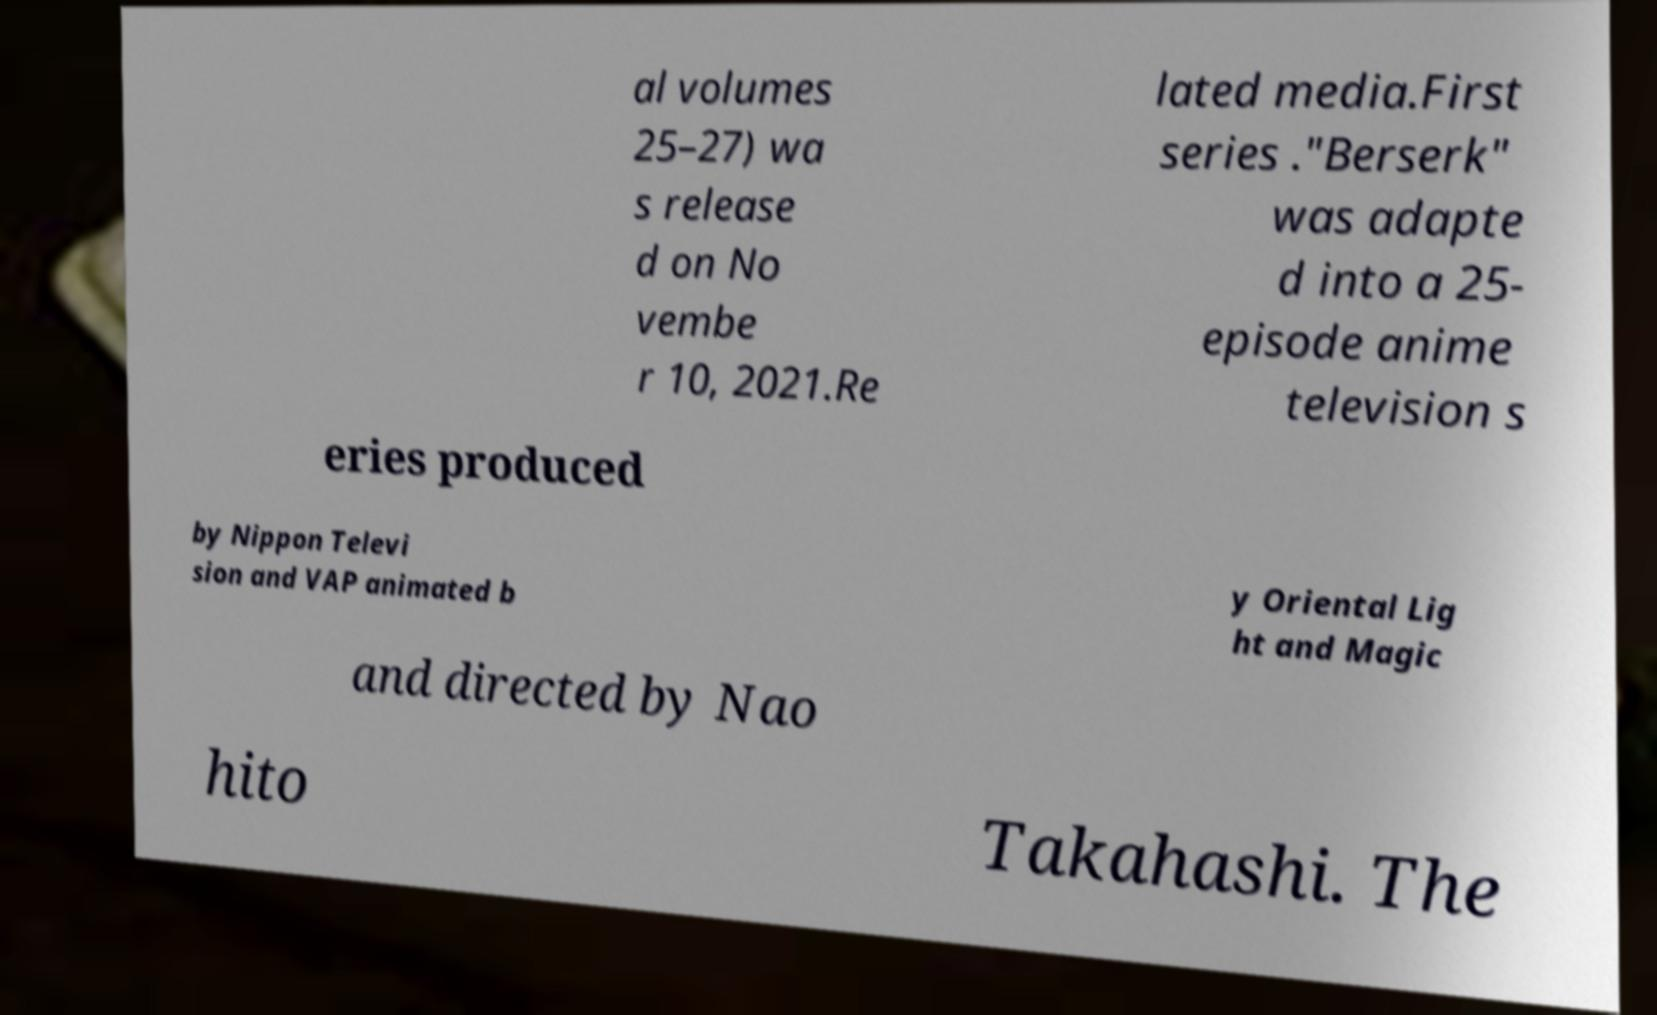What messages or text are displayed in this image? I need them in a readable, typed format. al volumes 25–27) wa s release d on No vembe r 10, 2021.Re lated media.First series ."Berserk" was adapte d into a 25- episode anime television s eries produced by Nippon Televi sion and VAP animated b y Oriental Lig ht and Magic and directed by Nao hito Takahashi. The 